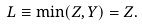<formula> <loc_0><loc_0><loc_500><loc_500>L \equiv \min ( Z , Y ) = Z .</formula> 